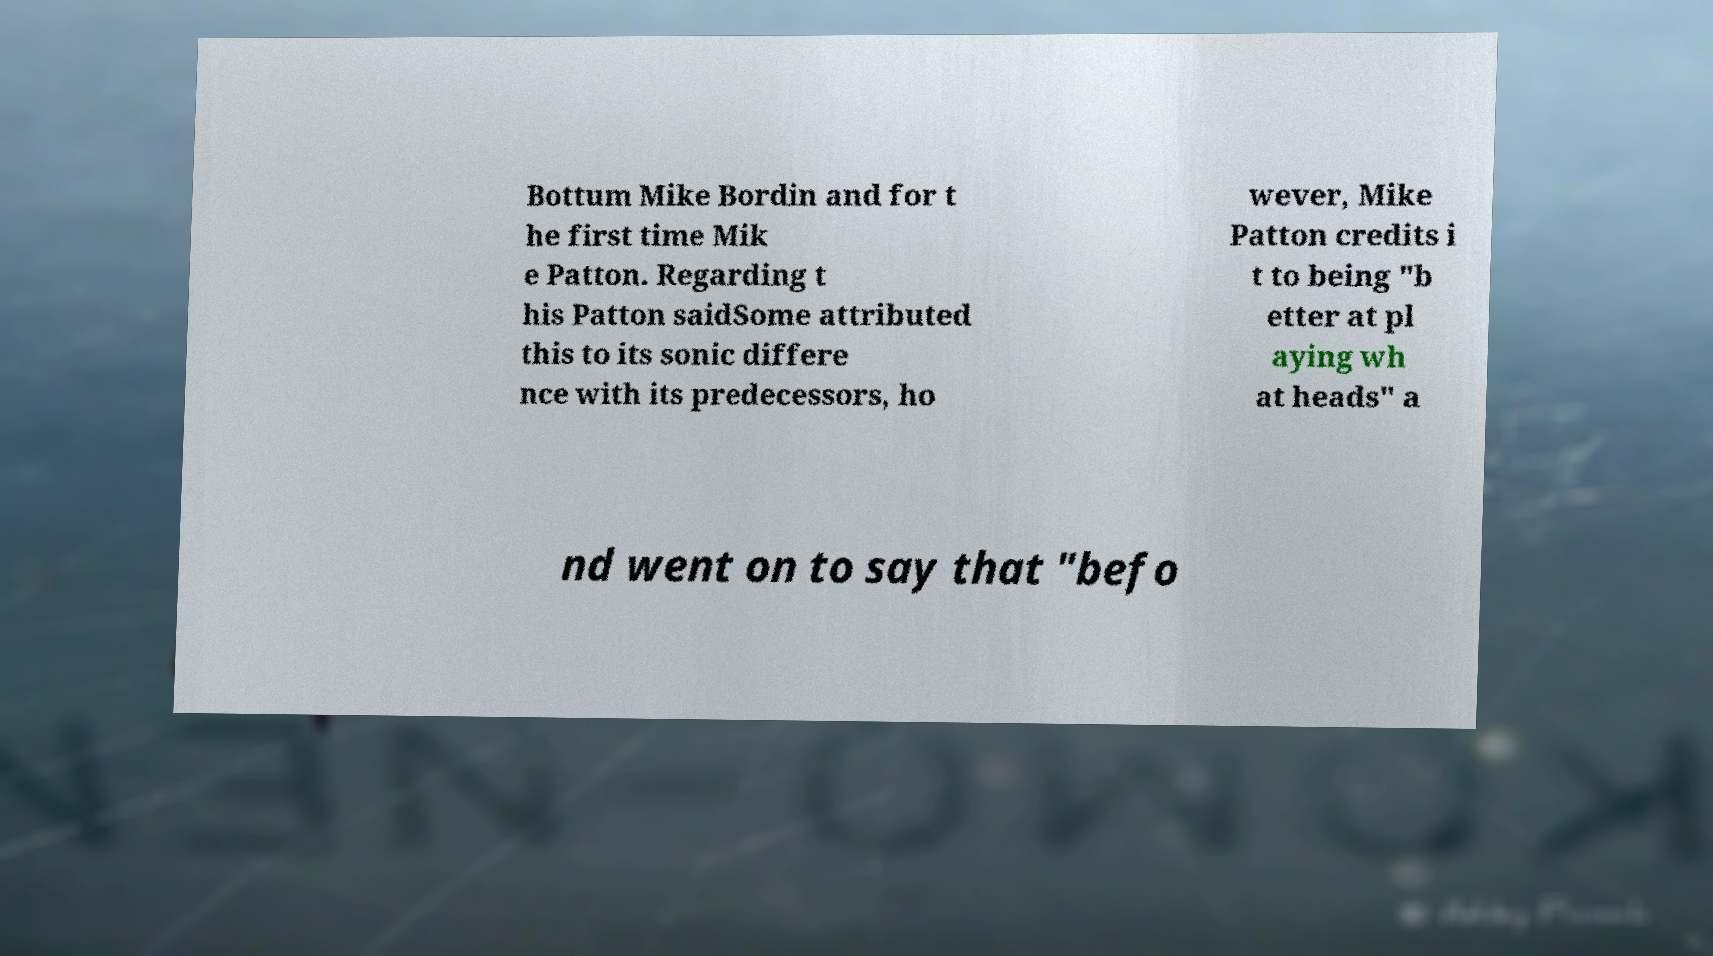What messages or text are displayed in this image? I need them in a readable, typed format. Bottum Mike Bordin and for t he first time Mik e Patton. Regarding t his Patton saidSome attributed this to its sonic differe nce with its predecessors, ho wever, Mike Patton credits i t to being "b etter at pl aying wh at heads" a nd went on to say that "befo 